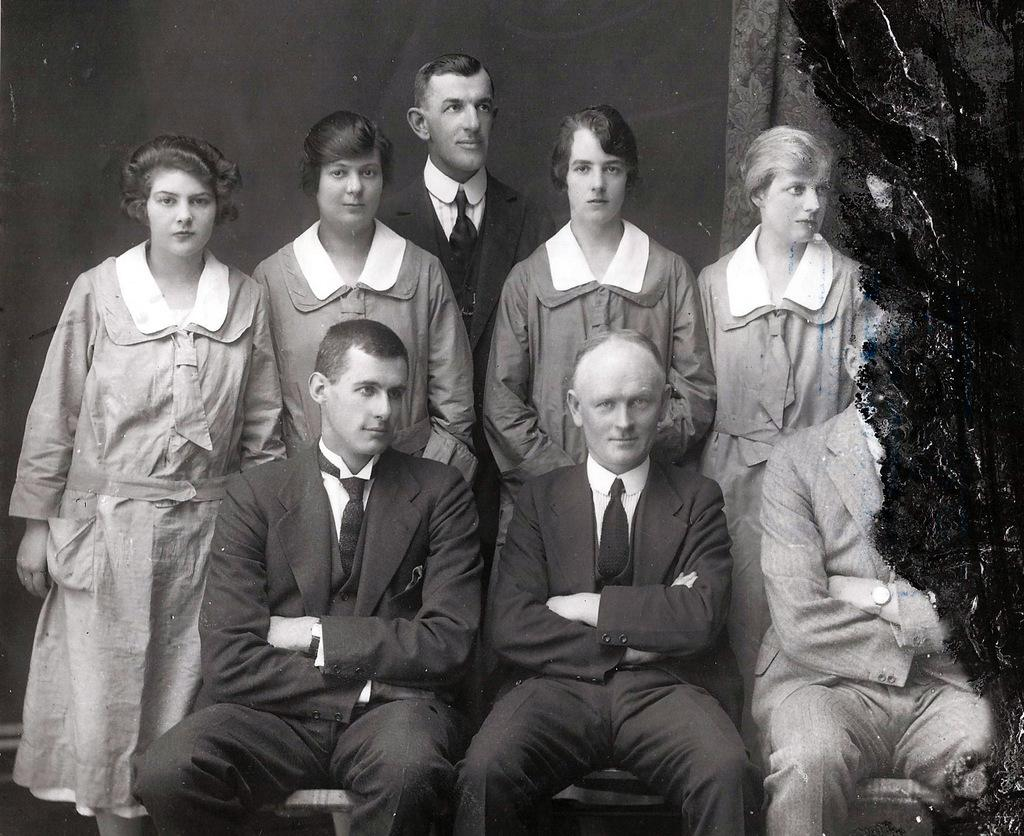What type of image is being described? The image is a photograph. What is happening in the center of the image? There are people standing and sitting in the center of the image. What type of cactus can be seen in the background of the image? There is no cactus present in the image. What territory is being claimed by the people in the image? The image does not depict any territorial claims or disputes. 